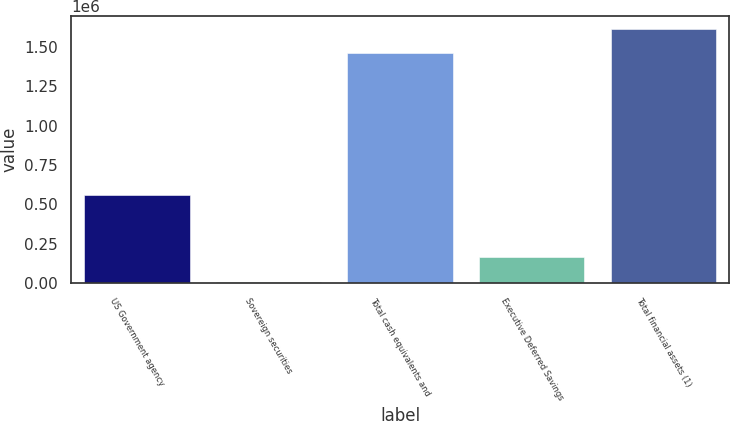Convert chart. <chart><loc_0><loc_0><loc_500><loc_500><bar_chart><fcel>US Government agency<fcel>Sovereign securities<fcel>Total cash equivalents and<fcel>Executive Deferred Savings<fcel>Total financial assets (1)<nl><fcel>556019<fcel>8976<fcel>1.45944e+06<fcel>163142<fcel>1.6136e+06<nl></chart> 